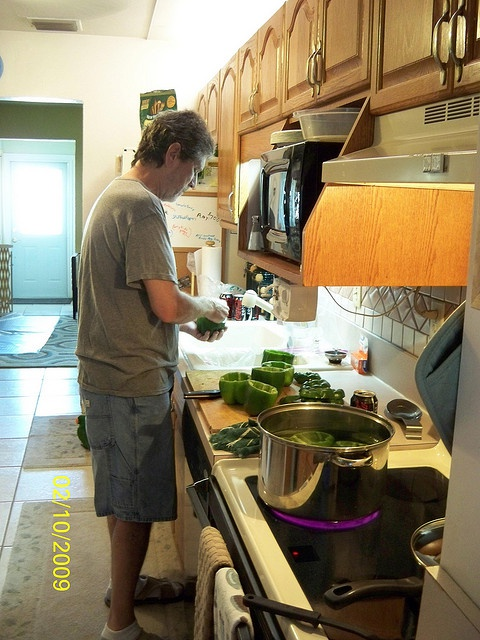Describe the objects in this image and their specific colors. I can see people in tan, black, and gray tones, oven in tan, black, and khaki tones, bowl in tan, black, olive, and maroon tones, microwave in tan, black, darkgray, and gray tones, and sink in tan, ivory, darkgray, beige, and gray tones in this image. 